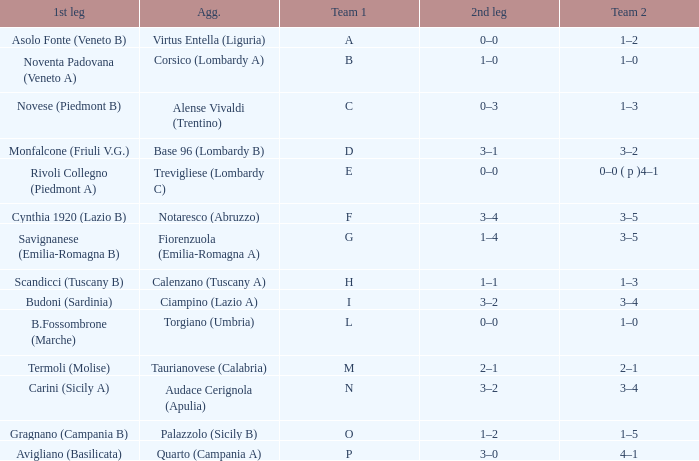What 1st leg has Alense Vivaldi (Trentino) as Agg.? Novese (Piedmont B). 